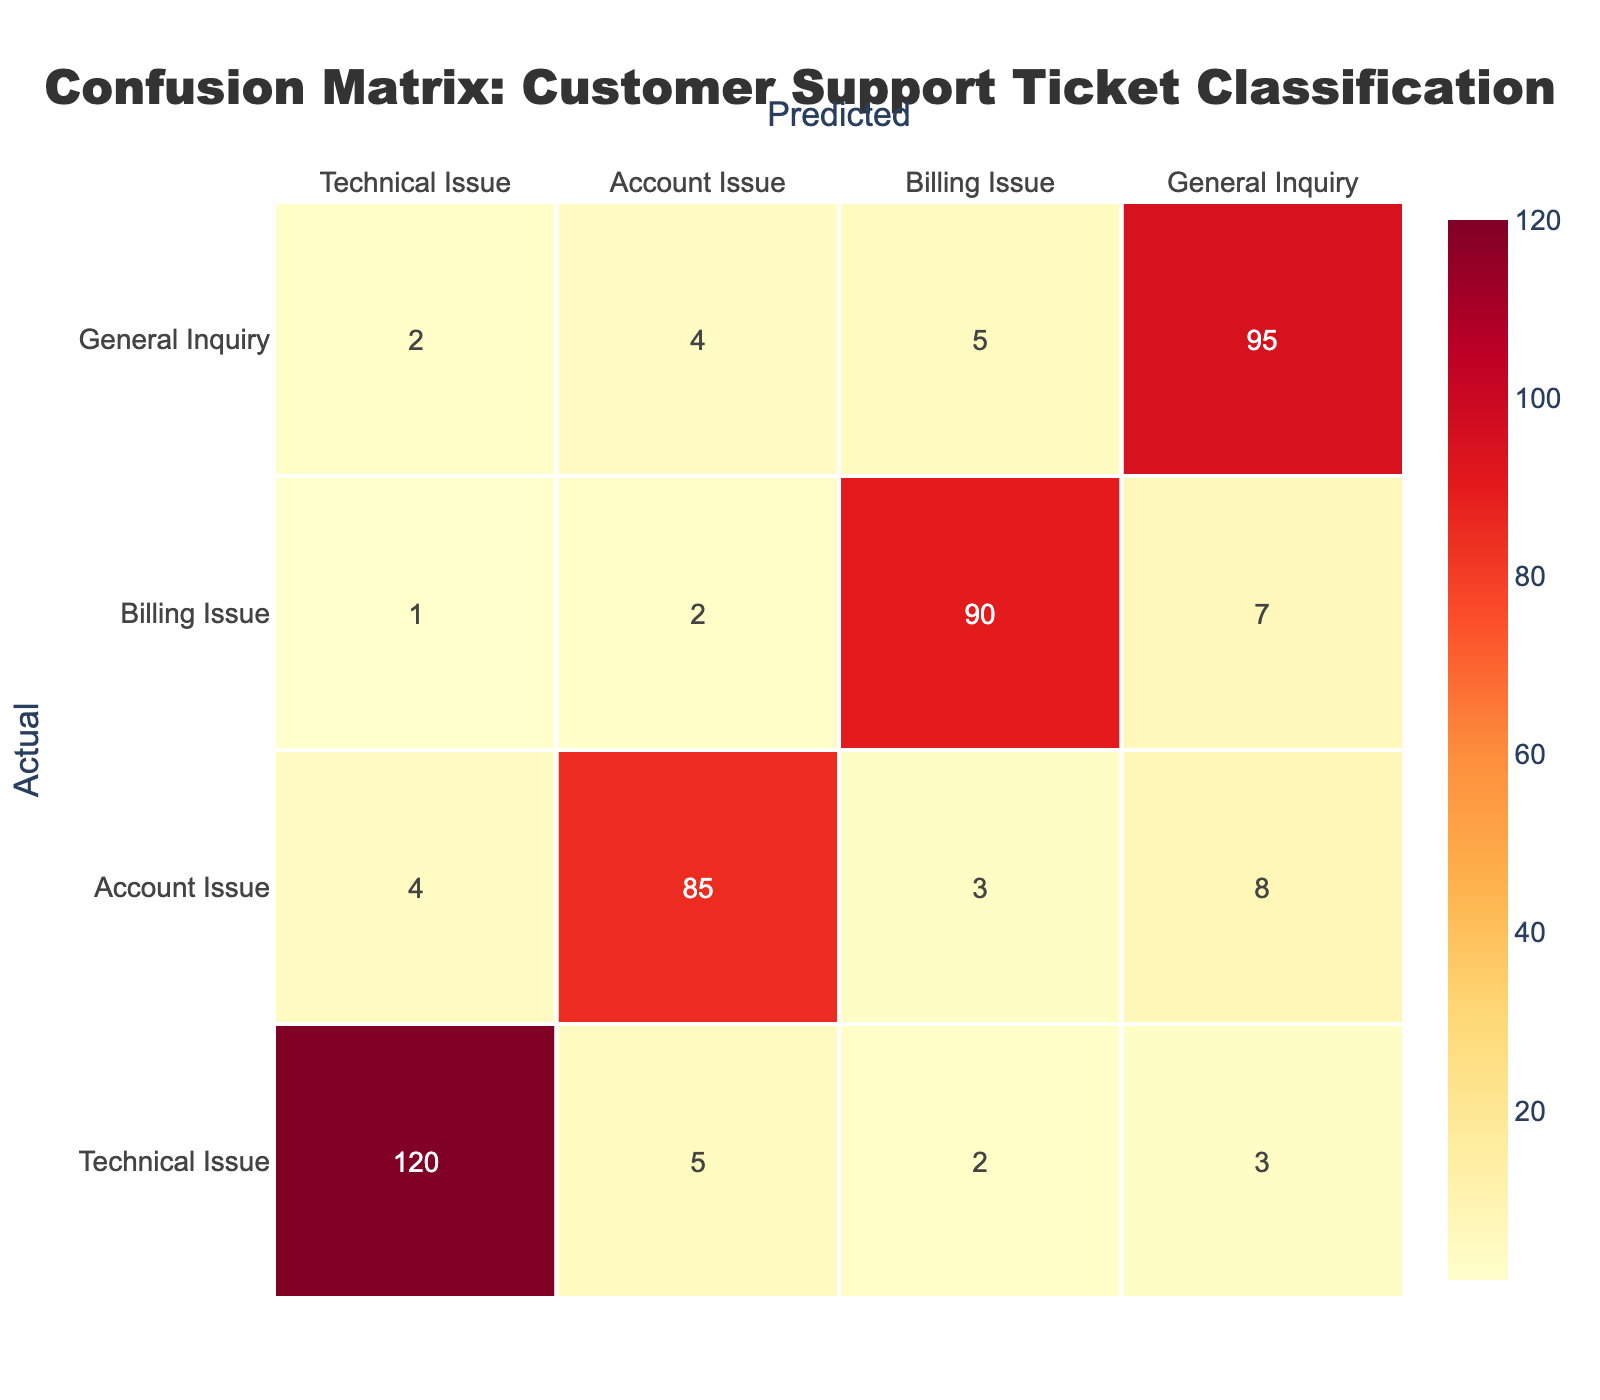What is the total number of Technical Issues predicted correctly? In the table, the value for Technical Issues predicted correctly is located at the intersection of the "Technical Issue" row and the "Technical Issue" column, which is 120.
Answer: 120 What is the total number of Account Issues that were predicted as General Inquiries? The value for Account Issues predicted as General Inquiries is found at the intersection of the "Account Issue" row and the "General Inquiry" column, which is 8.
Answer: 8 Is it true that more General Inquiries were wrongly classified as Billing Issues than as Technical Issues? The number of General Inquiries wrongly classified as Billing Issues is 5, while the number wrongly classified as Technical Issues is 2. Since 5 > 2, the statement is true.
Answer: Yes What is the total number of misclassified tickets for Billing Issues? To find the total misclassified tickets for Billing Issues, we add all the values in the Billing Issue column excluding the correct classification: 1 (Technical) + 2 (Account) + 7 (General) = 10.
Answer: 10 What is the average number of misclassifications across all ticket types? First, we need to total the misclassifications for each type: Total = 5 (Tech) + 4 (Account) + 2 (Billing) + 4 (Gen) = 15. The number of ticket types is 4. So, the average is 15/4 = 3.75.
Answer: 3.75 How many more Technical Issues were predicted than the total number of General Inquiries? The number of Technical Issues predicted is 120, and the total number of General Inquiries predicted is 95. So, the difference is 120 - 95 = 25.
Answer: 25 Which type of issue has the highest number of misclassifications? To find out, we need to add up all the misclassified counts for each type: Technical Issues (10), Account Issues (15), Billing Issues (10), and General Inquiries (11). The highest total is for Account Issues at 15.
Answer: Account Issue What is the total number of tickets classified? The total number of tickets can be calculated by adding all the values in the matrix: 120 + 5 + 2 + 3 + 4 + 85 + 3 + 8 + 1 + 2 + 90 + 7 + 2 + 4 + 5 + 95 = 335.
Answer: 335 What are the chances that an Account Issue is incorrectly classified as a Technical Issue? The number of Account Issues misclassified as Technical Issues is 4 and there are a total of 100 Account Issues (85 + 4 + 3 + 8). The probability is 4/100 = 0.04 or 4%.
Answer: 4% 